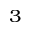<formula> <loc_0><loc_0><loc_500><loc_500>^ { 3 }</formula> 